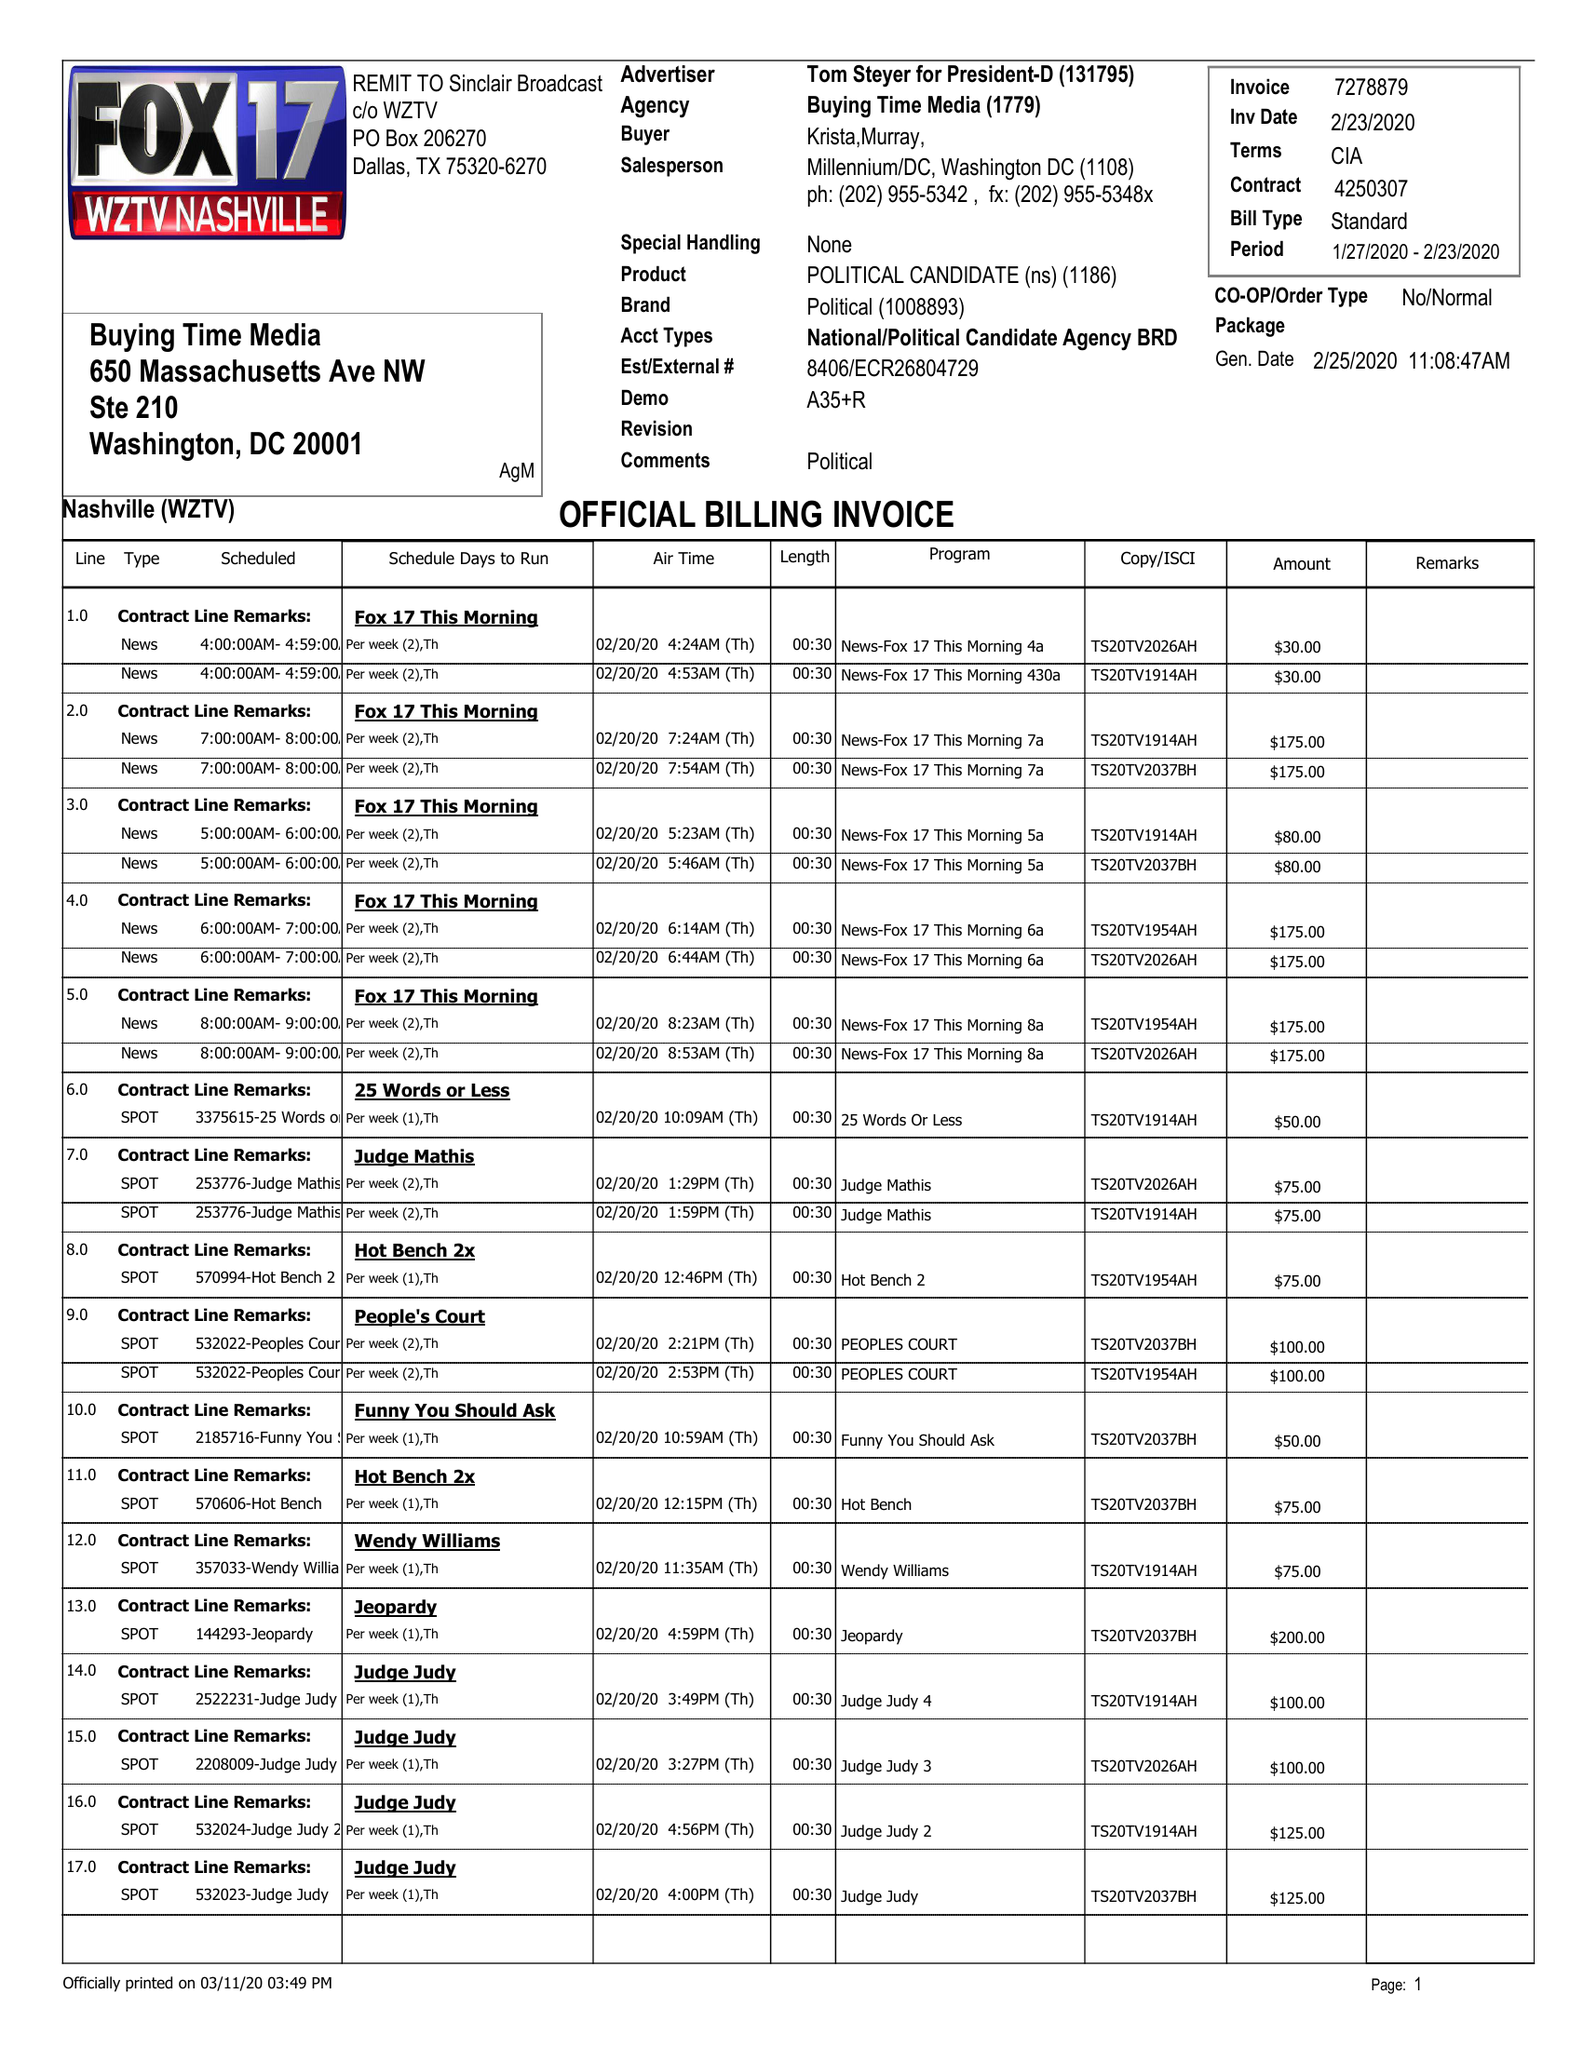What is the value for the advertiser?
Answer the question using a single word or phrase. TOM STEYER FOR PRESIDENT-D 